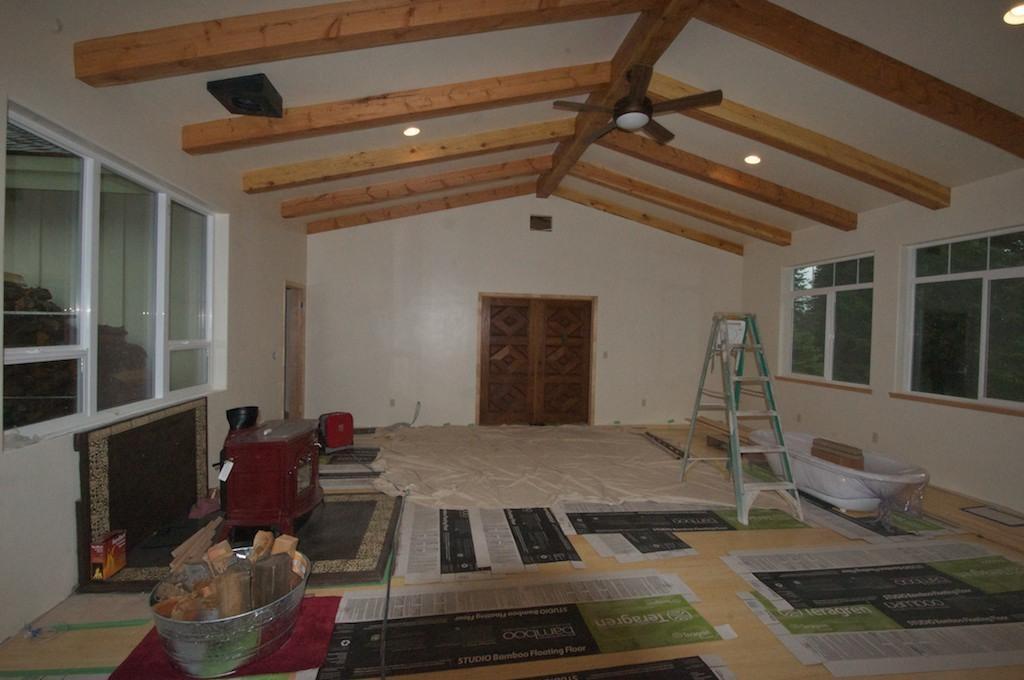In one or two sentences, can you explain what this image depicts? In this picture I can see windows, lights, fan, ladder, bath tub, cloth, papers, there are wooden pieces in a bowl, there is a cupboard, doors and there are some other items in a room. 